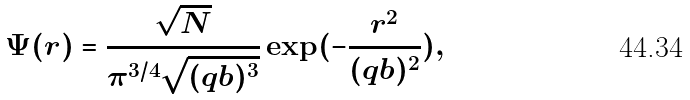Convert formula to latex. <formula><loc_0><loc_0><loc_500><loc_500>\Psi ( r ) = \frac { \sqrt { N } } { \pi ^ { 3 / 4 } \sqrt { ( q b ) ^ { 3 } } } \exp ( - \frac { r ^ { 2 } } { ( q b ) ^ { 2 } } ) ,</formula> 